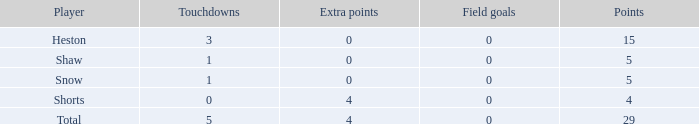What is the aggregate of all the touchdowns when the player had over 0 extra points and less than 0 field goals? None. Would you be able to parse every entry in this table? {'header': ['Player', 'Touchdowns', 'Extra points', 'Field goals', 'Points'], 'rows': [['Heston', '3', '0', '0', '15'], ['Shaw', '1', '0', '0', '5'], ['Snow', '1', '0', '0', '5'], ['Shorts', '0', '4', '0', '4'], ['Total', '5', '4', '0', '29']]} 